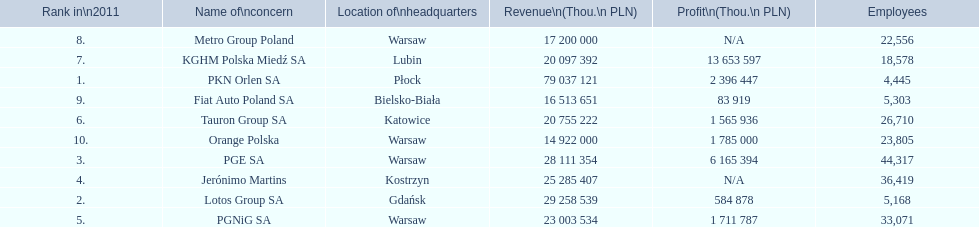Which company had the least revenue? Orange Polska. 